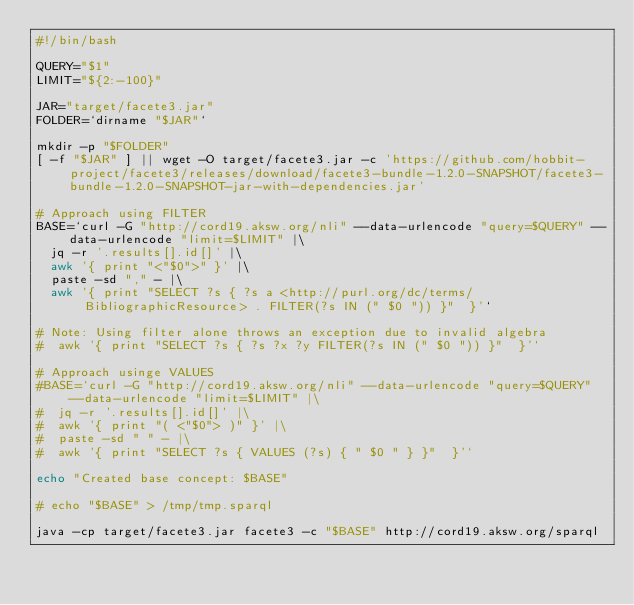<code> <loc_0><loc_0><loc_500><loc_500><_Bash_>#!/bin/bash

QUERY="$1"
LIMIT="${2:-100}"

JAR="target/facete3.jar"
FOLDER=`dirname "$JAR"`

mkdir -p "$FOLDER"
[ -f "$JAR" ] || wget -O target/facete3.jar -c 'https://github.com/hobbit-project/facete3/releases/download/facete3-bundle-1.2.0-SNAPSHOT/facete3-bundle-1.2.0-SNAPSHOT-jar-with-dependencies.jar'

# Approach using FILTER
BASE=`curl -G "http://cord19.aksw.org/nli" --data-urlencode "query=$QUERY" --data-urlencode "limit=$LIMIT" |\
  jq -r '.results[].id[]' |\
  awk '{ print "<"$0">" }' |\
  paste -sd "," - |\
  awk '{ print "SELECT ?s { ?s a <http://purl.org/dc/terms/BibliographicResource> . FILTER(?s IN (" $0 ")) }"  }'`

# Note: Using filter alone throws an exception due to invalid algebra
#  awk '{ print "SELECT ?s { ?s ?x ?y FILTER(?s IN (" $0 ")) }"  }'`

# Approach usinge VALUES
#BASE=`curl -G "http://cord19.aksw.org/nli" --data-urlencode "query=$QUERY" --data-urlencode "limit=$LIMIT" |\
#  jq -r '.results[].id[]' |\
#  awk '{ print "( <"$0"> )" }' |\
#  paste -sd " " - |\
#  awk '{ print "SELECT ?s { VALUES (?s) { " $0 " } }"  }'`

echo "Created base concept: $BASE"

# echo "$BASE" > /tmp/tmp.sparql

java -cp target/facete3.jar facete3 -c "$BASE" http://cord19.aksw.org/sparql

</code> 